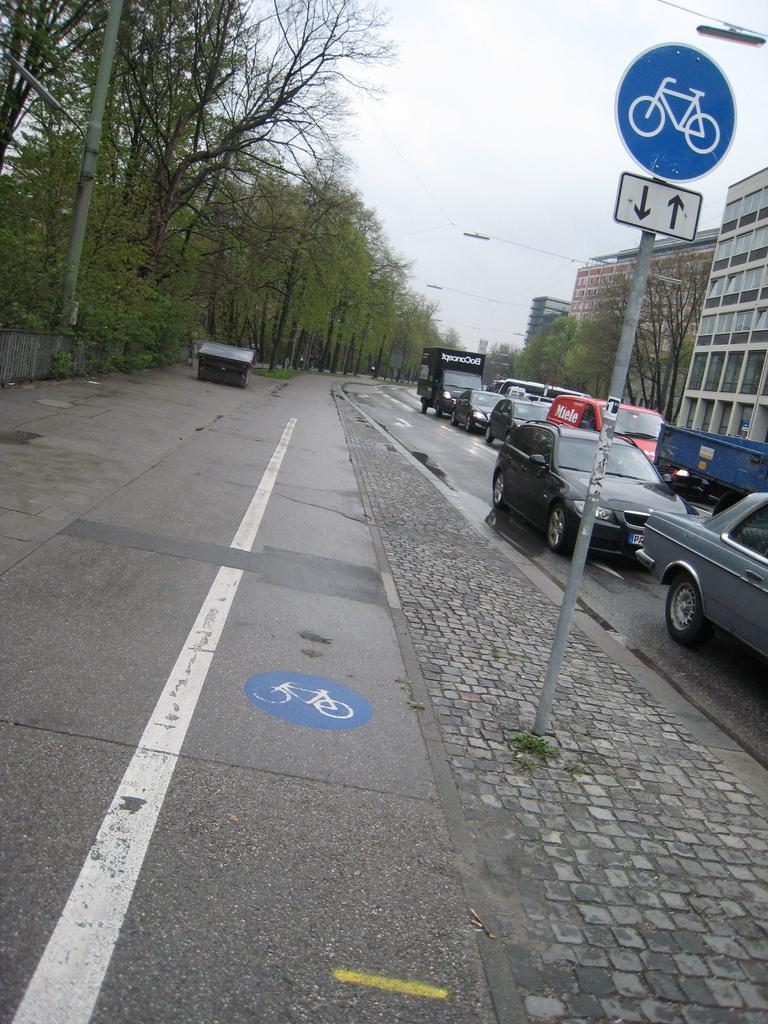Can you describe this image briefly? In this image we can see some vehicles on the road and there is a pole with sign boards and there is a sidewalk. There are some trees and buildings and we can see the sky at the top. 